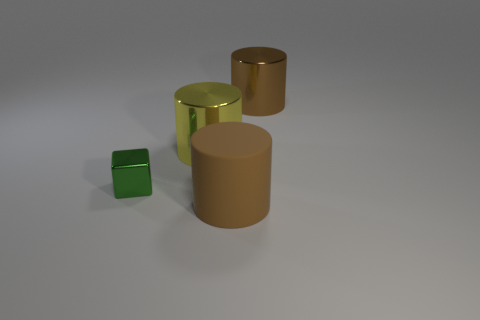Add 2 small purple shiny cubes. How many objects exist? 6 Subtract all blocks. How many objects are left? 3 Subtract 0 yellow balls. How many objects are left? 4 Subtract all large yellow objects. Subtract all big yellow cylinders. How many objects are left? 2 Add 2 big brown cylinders. How many big brown cylinders are left? 4 Add 1 big cylinders. How many big cylinders exist? 4 